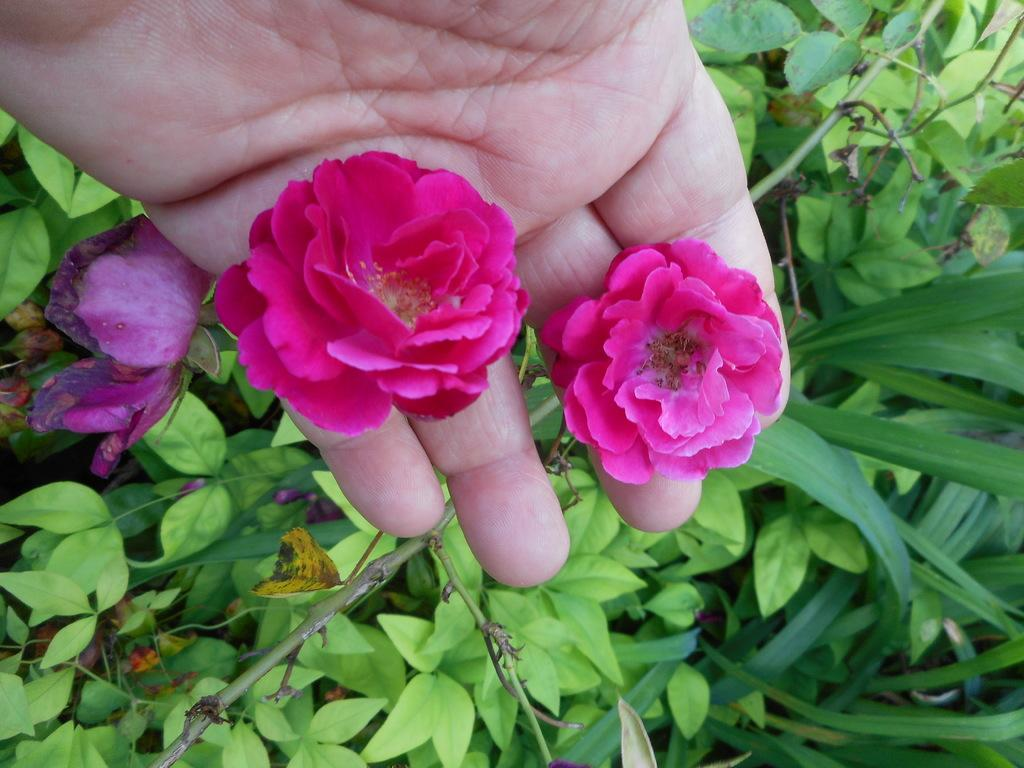What type of living organisms can be seen in the image? Plants and flowers are visible in the image. What is the human hand holding in the image? A human hand is holding flowers in the image. What color is the crayon being used to draw the frame in the image? There is no crayon or frame present in the image. What type of work does the farmer do in the image? There is no farmer present in the image. 